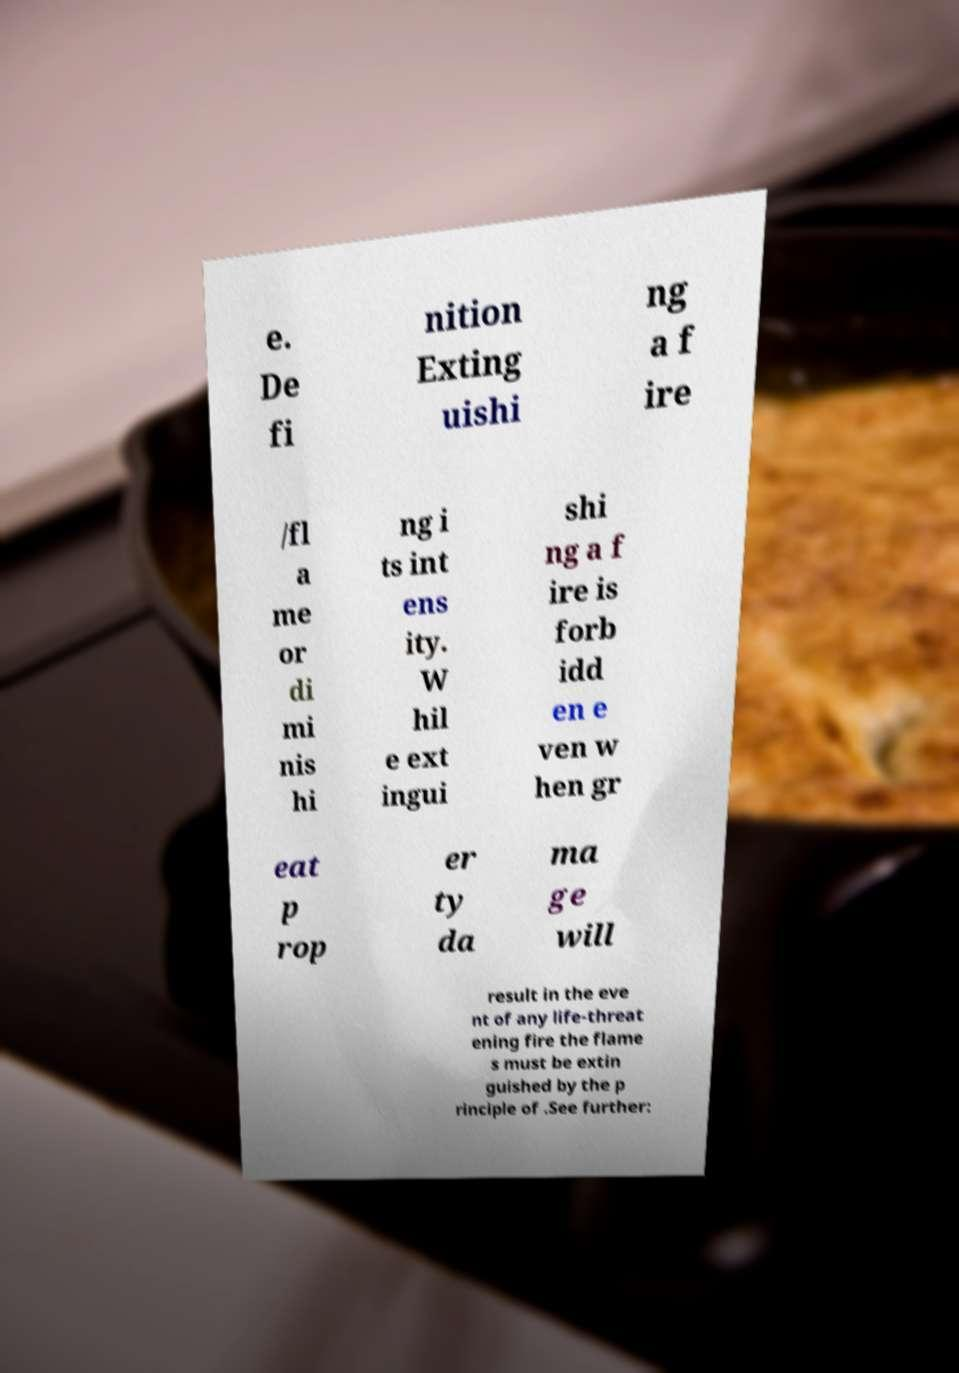Please identify and transcribe the text found in this image. e. De fi nition Exting uishi ng a f ire /fl a me or di mi nis hi ng i ts int ens ity. W hil e ext ingui shi ng a f ire is forb idd en e ven w hen gr eat p rop er ty da ma ge will result in the eve nt of any life-threat ening fire the flame s must be extin guished by the p rinciple of .See further: 